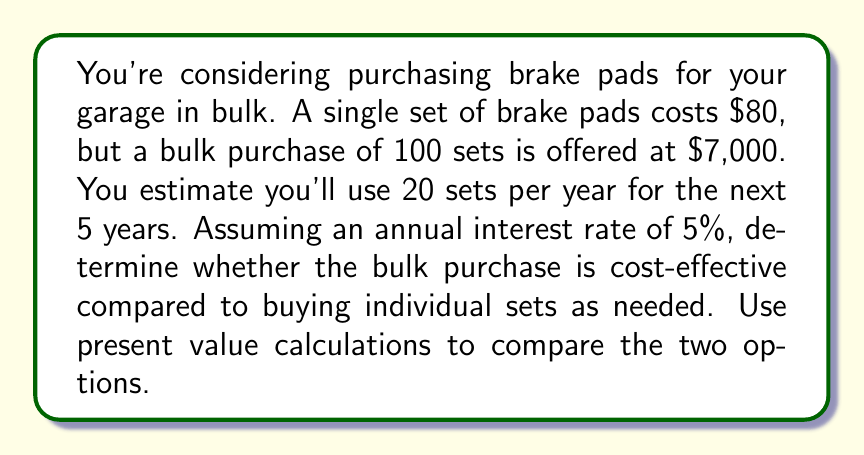Solve this math problem. To solve this problem, we need to compare the present value of the bulk purchase with the present value of buying individual sets over 5 years.

1. Bulk purchase option:
   The cost is $7,000 upfront, so its present value is simply $7,000.

2. Individual purchase option:
   We need to calculate the present value of 20 sets per year for 5 years.
   
   Annual cost: $80 * 20 = $1,600
   
   We'll use the present value of an annuity formula:

   $$ PV = A \frac{1 - (1+r)^{-n}}{r} $$

   Where:
   $A$ = Annual payment ($1,600)
   $r$ = Annual interest rate (5% = 0.05)
   $n$ = Number of years (5)

   Plugging in the values:

   $$ PV = 1600 \frac{1 - (1+0.05)^{-5}}{0.05} $$

   $$ PV = 1600 \frac{1 - 0.7835}{0.05} $$

   $$ PV = 1600 * 4.3295 $$

   $$ PV = 6,927.20 $$

3. Comparison:
   Bulk purchase PV: $7,000
   Individual purchase PV: $6,927.20

   The difference is $7,000 - $6,927.20 = $72.80
Answer: The bulk purchase is not cost-effective. Buying individual sets as needed has a lower present value by $72.80, making it the more economical choice. 